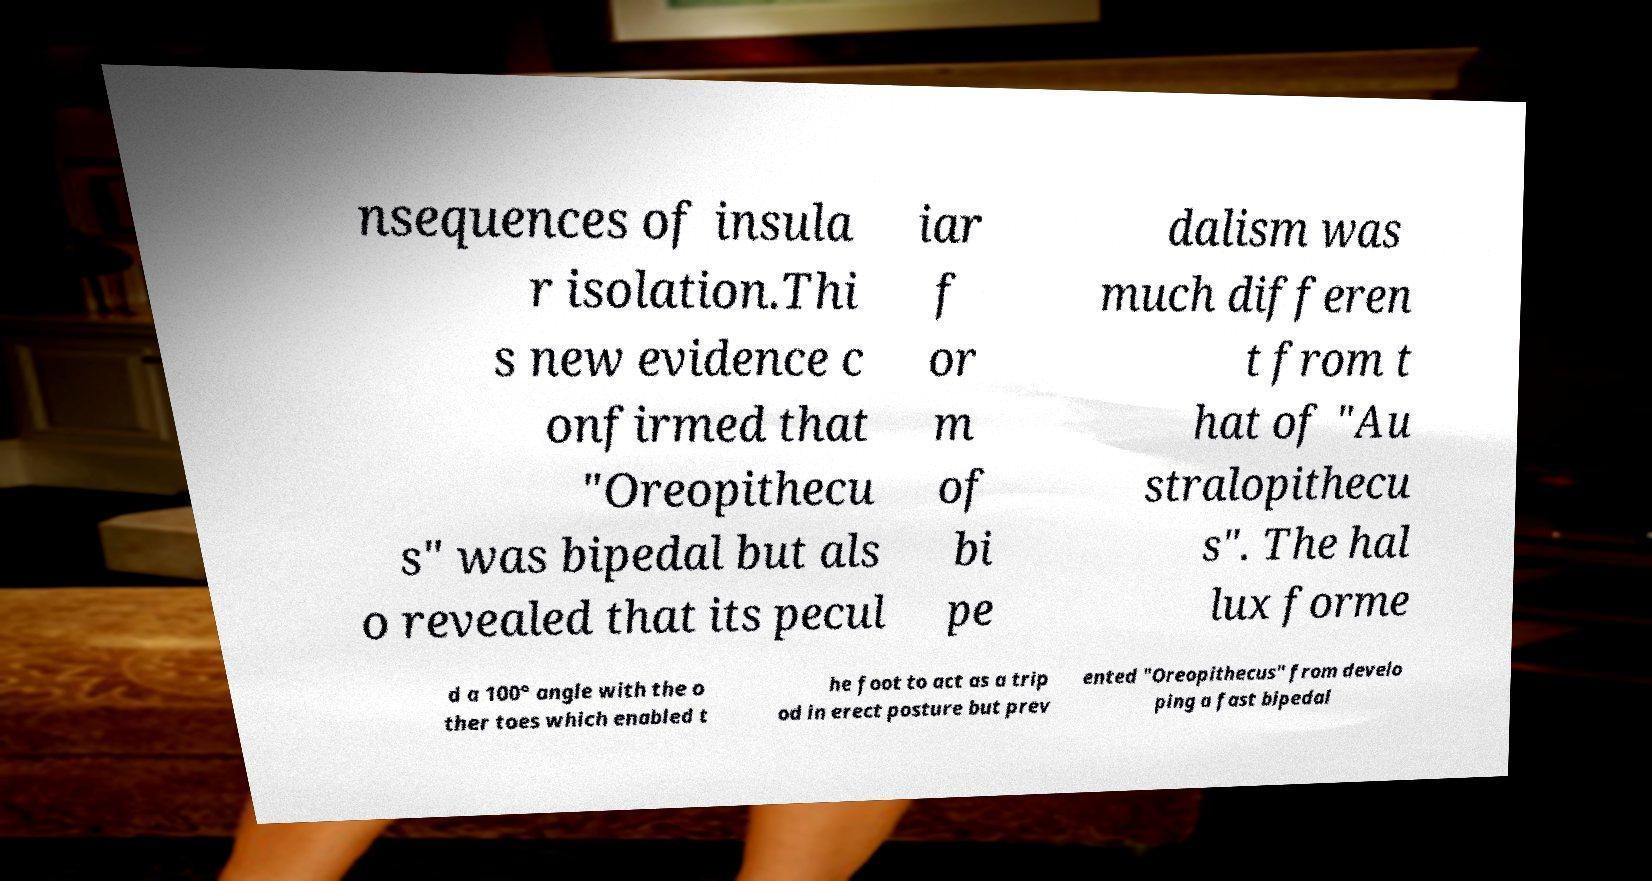For documentation purposes, I need the text within this image transcribed. Could you provide that? nsequences of insula r isolation.Thi s new evidence c onfirmed that "Oreopithecu s" was bipedal but als o revealed that its pecul iar f or m of bi pe dalism was much differen t from t hat of "Au stralopithecu s". The hal lux forme d a 100° angle with the o ther toes which enabled t he foot to act as a trip od in erect posture but prev ented "Oreopithecus" from develo ping a fast bipedal 